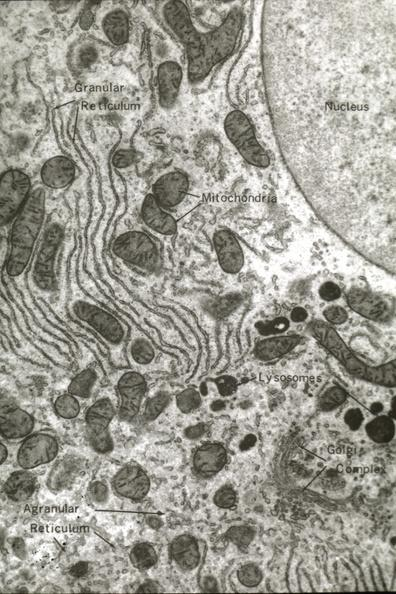does granulosa cell tumor show structures labeled?
Answer the question using a single word or phrase. No 